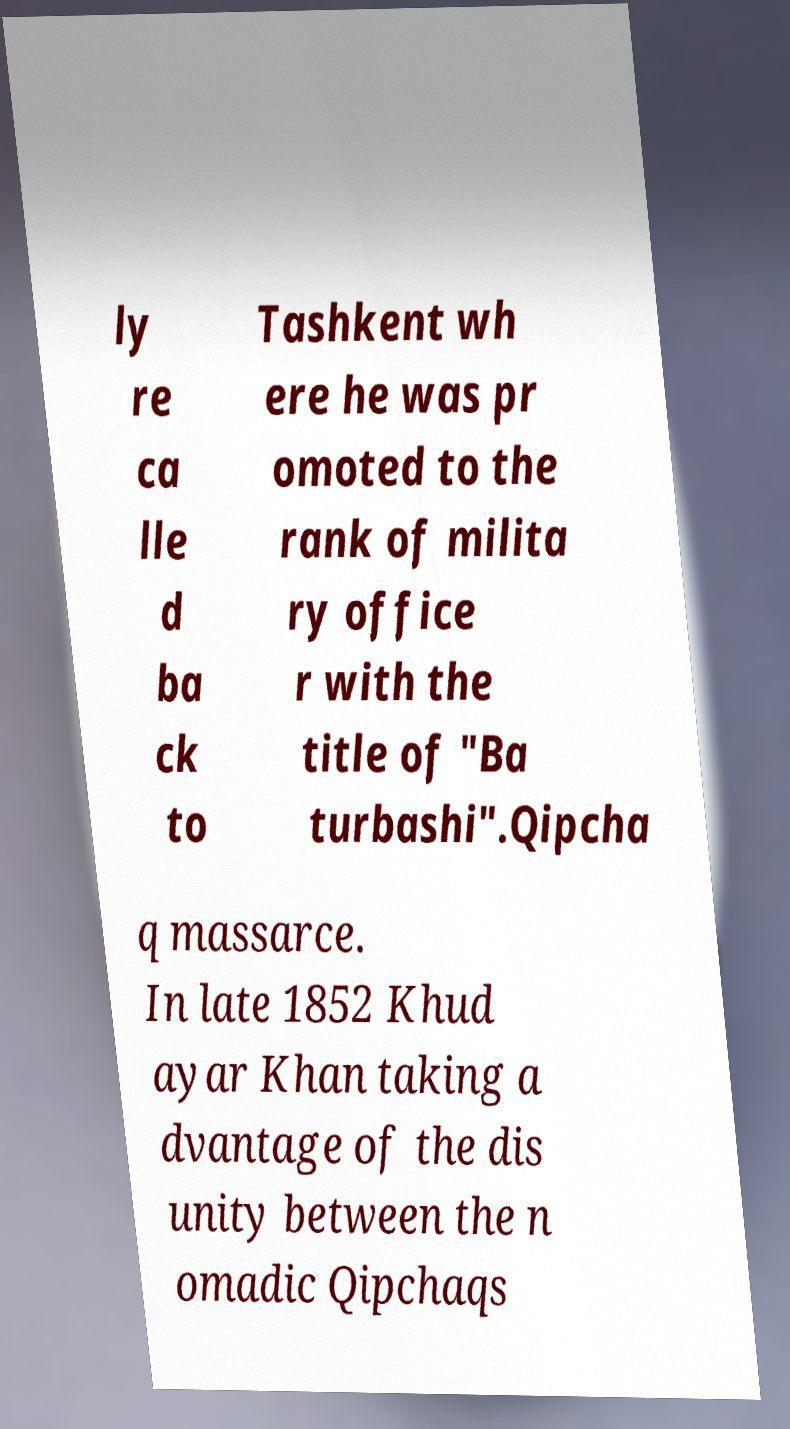Please read and relay the text visible in this image. What does it say? ly re ca lle d ba ck to Tashkent wh ere he was pr omoted to the rank of milita ry office r with the title of "Ba turbashi".Qipcha q massarce. In late 1852 Khud ayar Khan taking a dvantage of the dis unity between the n omadic Qipchaqs 